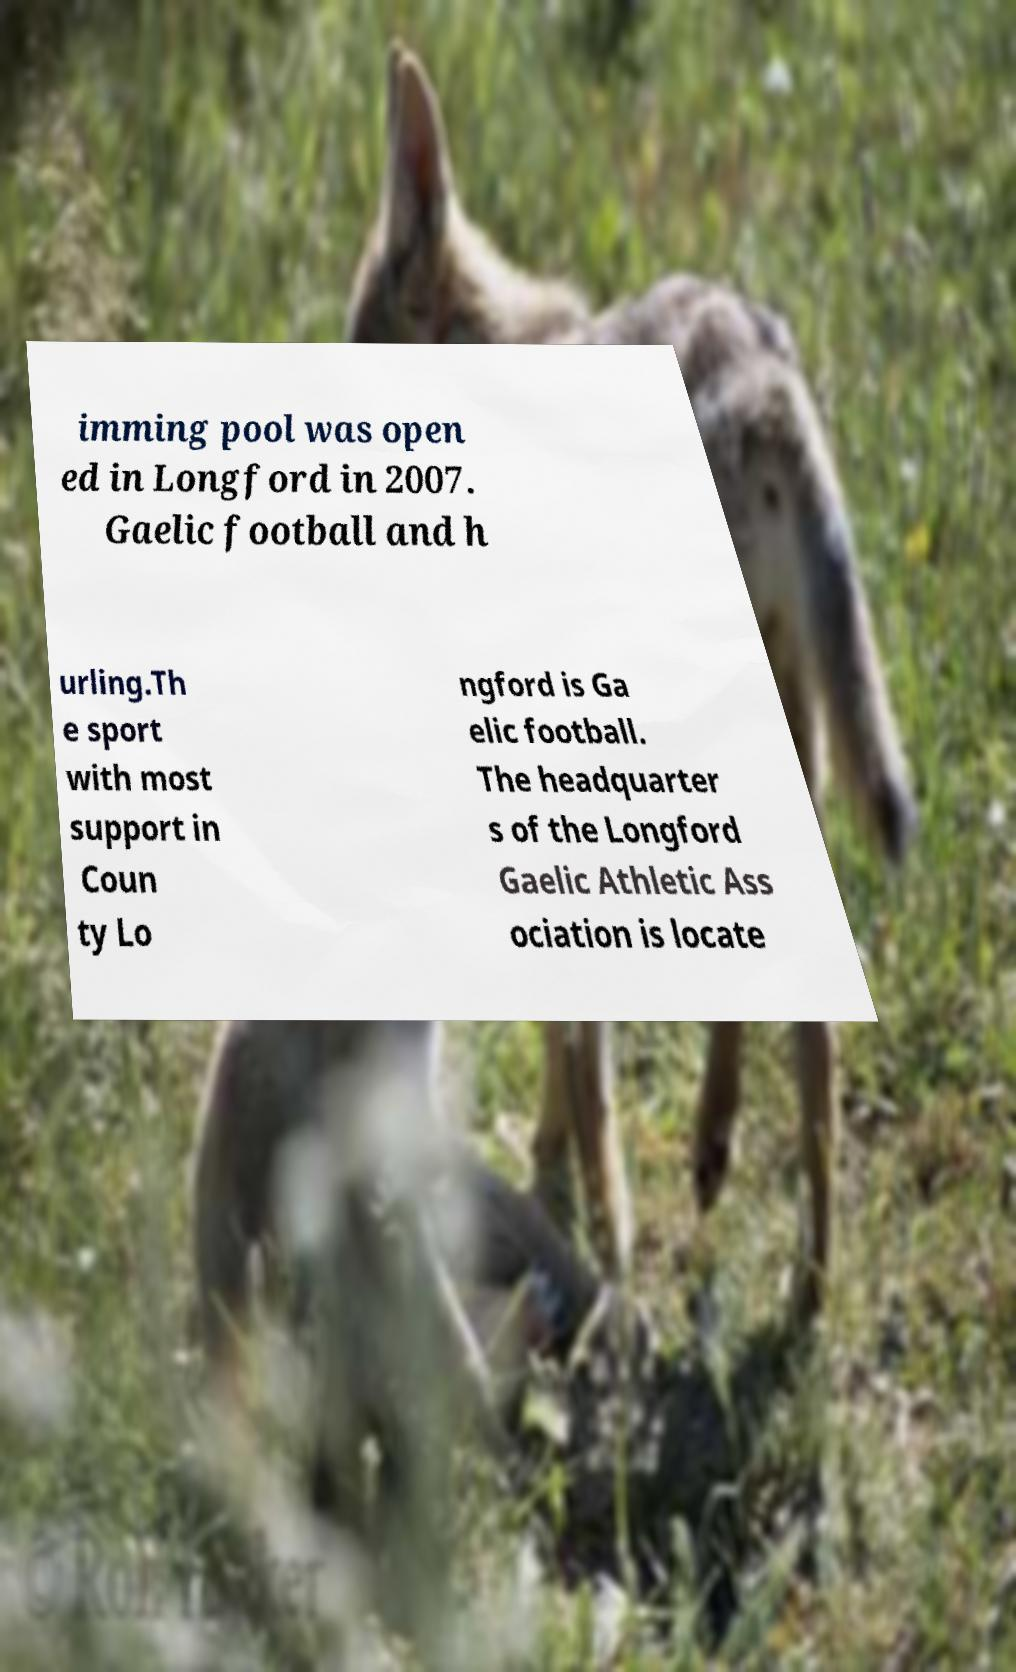Can you read and provide the text displayed in the image?This photo seems to have some interesting text. Can you extract and type it out for me? imming pool was open ed in Longford in 2007. Gaelic football and h urling.Th e sport with most support in Coun ty Lo ngford is Ga elic football. The headquarter s of the Longford Gaelic Athletic Ass ociation is locate 